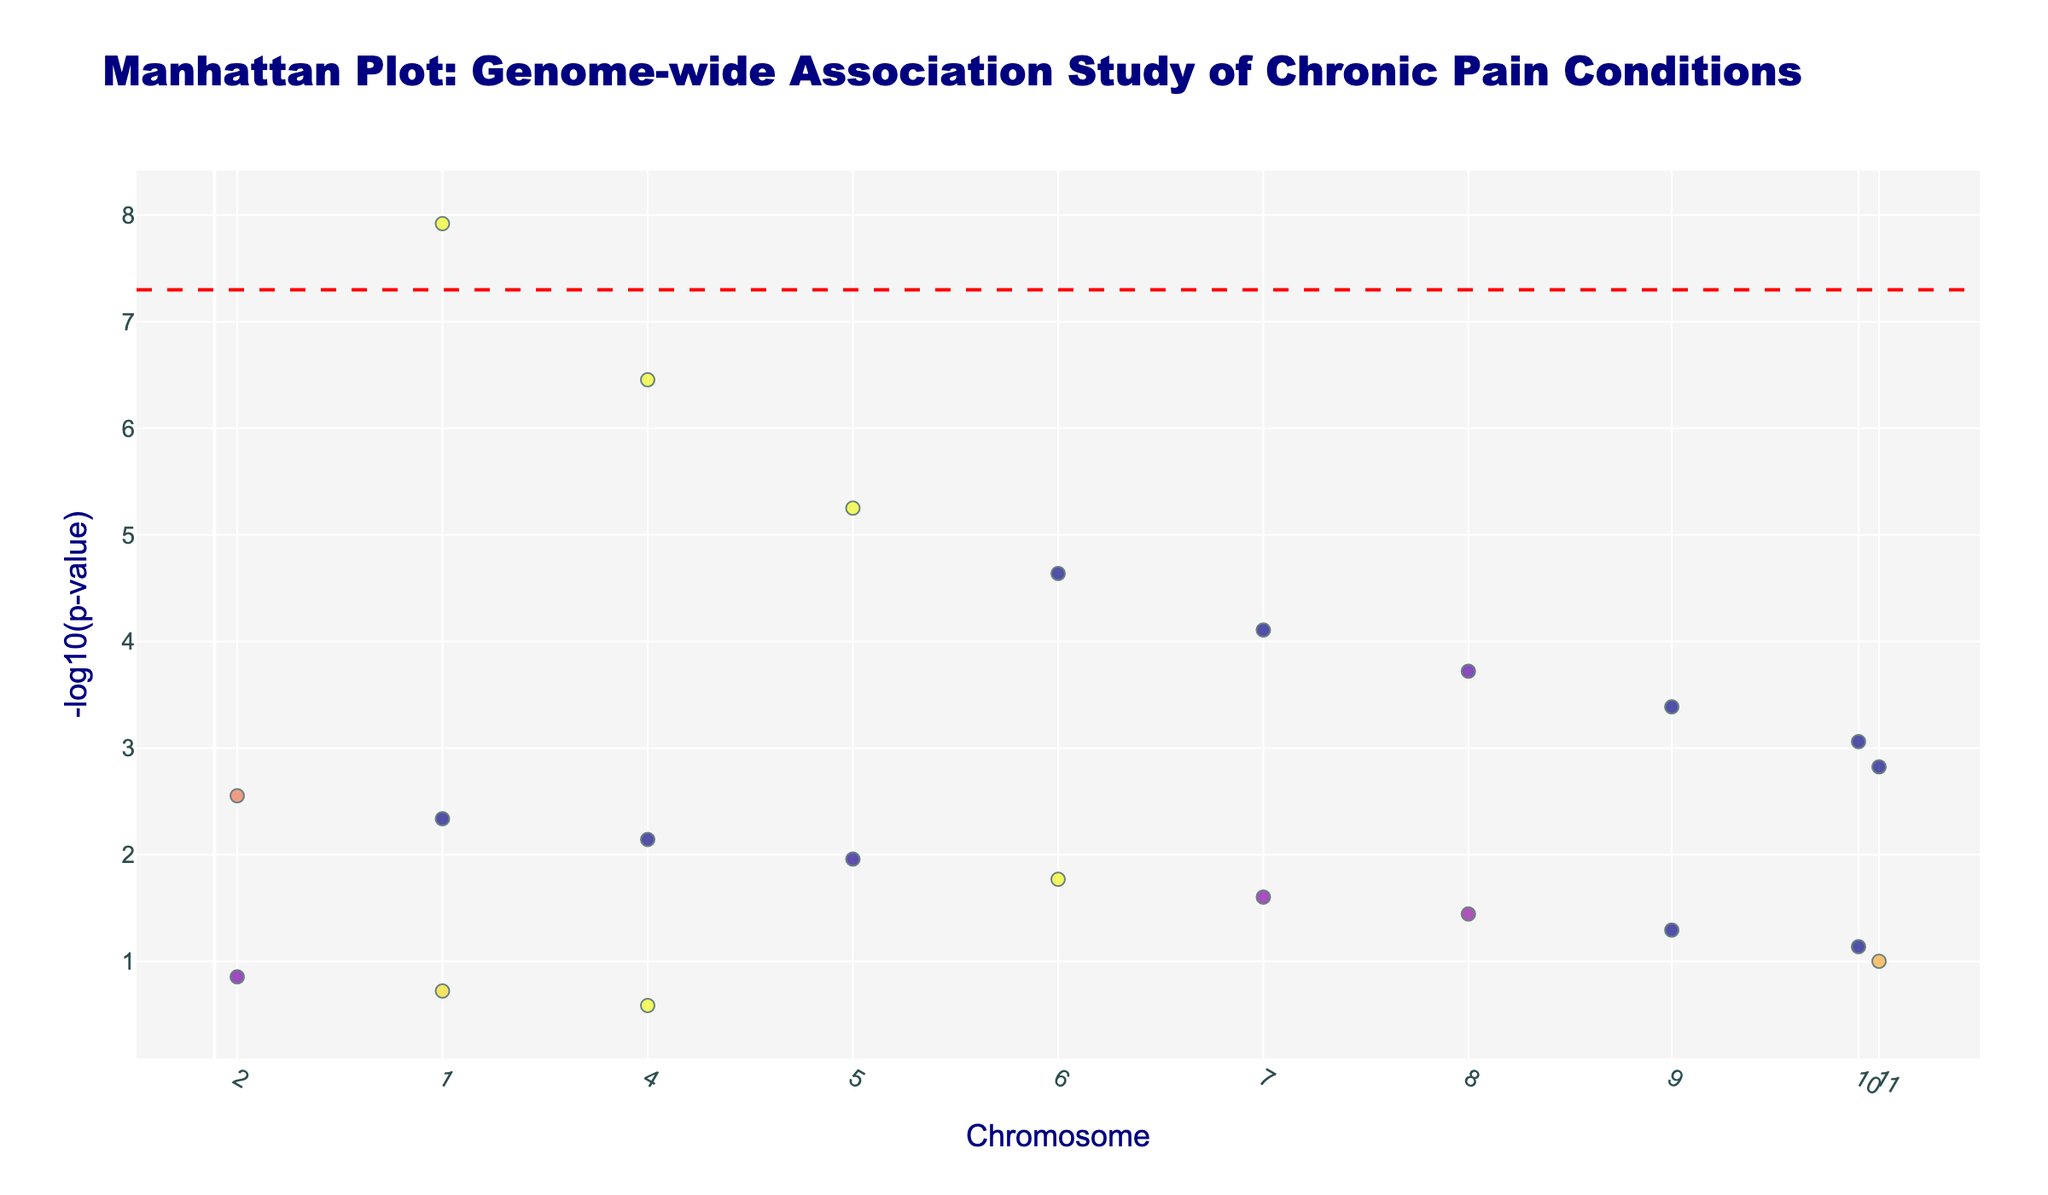What's the title of the figure? Look at the top of the figure where the title is usually displayed; it says "Manhattan Plot: Genome-wide Association Study of Chronic Pain Conditions"
Answer: Manhattan Plot: Genome-wide Association Study of Chronic Pain Conditions Which chromosome has the highest point in the plot? Identify the chromosome with the highest point along the y-axis on the plot. The highest point represents the lowest p-value (most significant SNP) on Chromosome 1.
Answer: Chromosome 1 How many chromosomes are represented in the plot? Count the distinct chromosomes listed along the x-axis or the different groups of points. Each group along the x-axis corresponds to a unique chromosome.
Answer: 22 What is the SNP with the lowest p-value, and which gene is it associated with? Look for the highest point on the y-axis, which represents the lowest p-value. The hover text should show the SNP and the gene name, here it is rs1234567, associated with the COMT gene.
Answer: rs1234567, COMT What does the red dashed line represent in the plot? Identify the significance line in the plot. It represents the genome-wide significance threshold, drawn at -log10(p-value) of 5e-8.
Answer: Genome-wide significance threshold Which gene is associated with the SNP rs8901234, and on which chromosome is it located? Find the SNP rs8901234 by identifying the points that provide hover text information. Check both the chromosome axis and the hover text. It's associated with the KCNQ2 gene on Chromosome 8.
Answer: KCNQ2, Chromosome 8 Compare the p-values of SNPs associated with the TRPV1 and TRPA1 genes. Which one is more significant? Look for SNPs associated with TRPV1 and TRPA1 genes in the plot. Compare their heights; TRPV1 has a more significant p-value, which means it is higher on the y-axis (-log10(p-value) of 1.9e-4).
Answer: TRPV1 Which chromosome has the lowest number of significant SNPs (p-value ≤ 1e-5)? Count the SNPs with p-values ≤ 1e-5 on each chromosome. Chromosome 4 and above typically have no such SNPs, whereas Chromosome 1 through 3 have at least one. Chromosome 4 has the least for this dataset (only one).
Answer: Chromosome 4 